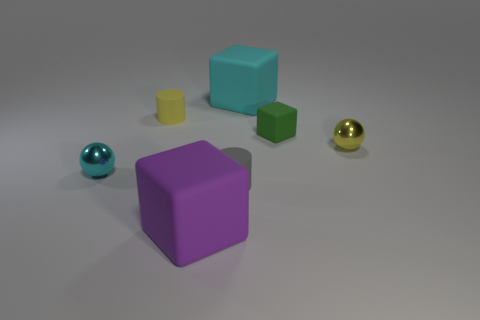What number of objects are either tiny cyan shiny objects or green blocks?
Provide a short and direct response. 2. Is the number of small cyan matte cylinders less than the number of yellow matte objects?
Give a very brief answer. Yes. What size is the green thing that is the same material as the small yellow cylinder?
Ensure brevity in your answer.  Small. How big is the purple matte block?
Offer a terse response. Large. There is a big cyan matte object; what shape is it?
Give a very brief answer. Cube. The purple matte object that is the same shape as the large cyan thing is what size?
Your response must be concise. Large. Are there any gray rubber objects that are on the right side of the big block behind the tiny metal object that is to the left of the yellow cylinder?
Your answer should be very brief. No. What is the ball behind the tiny cyan shiny thing made of?
Make the answer very short. Metal. How many large objects are either green matte blocks or cyan matte cylinders?
Ensure brevity in your answer.  0. Do the block that is behind the yellow rubber cylinder and the small green rubber object have the same size?
Your answer should be compact. No. 